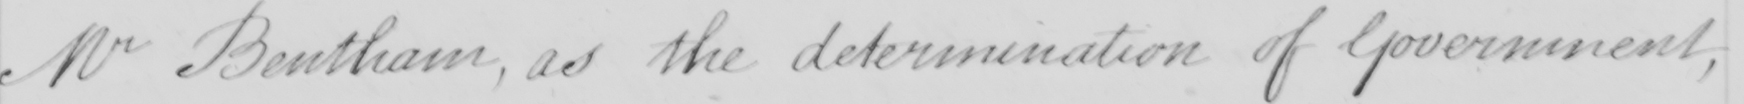What does this handwritten line say? Mr Bentham, as the determination of Government, 